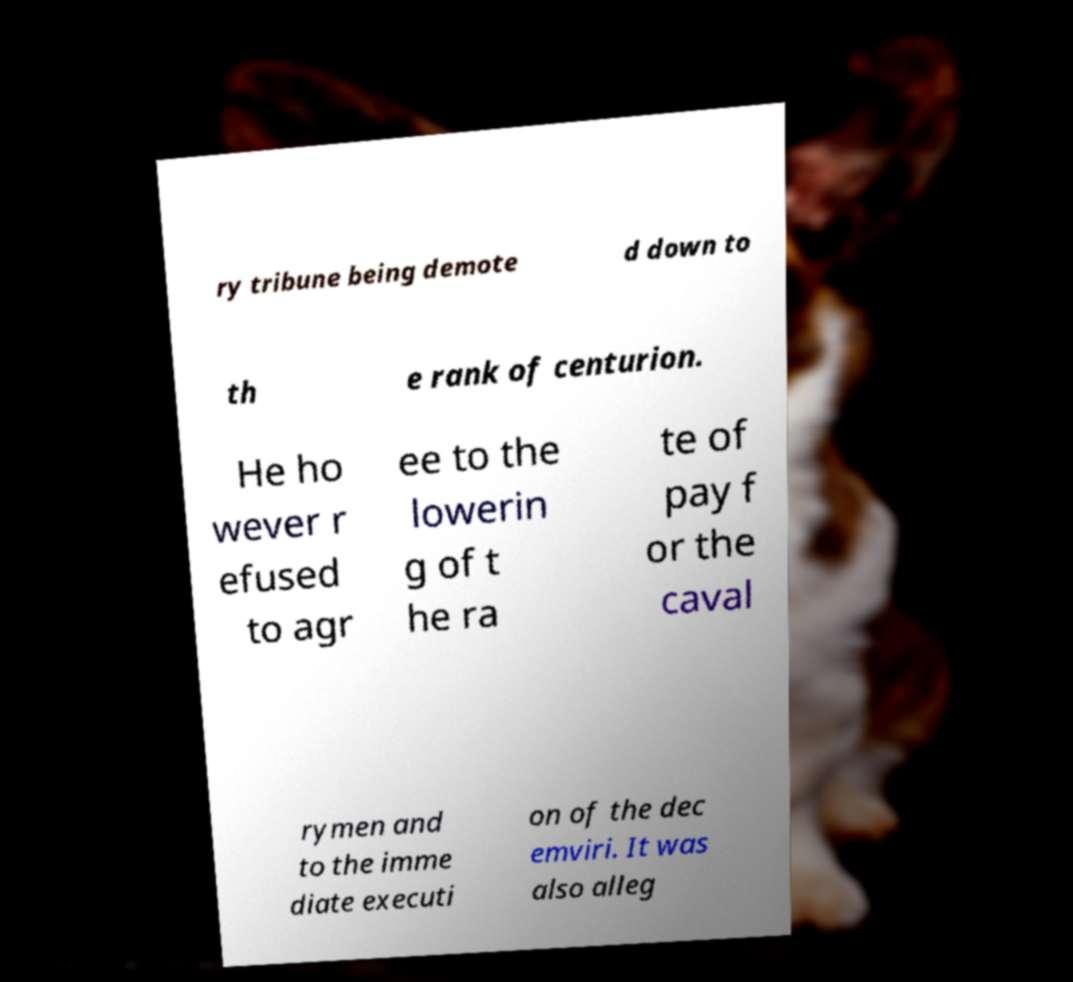Please identify and transcribe the text found in this image. ry tribune being demote d down to th e rank of centurion. He ho wever r efused to agr ee to the lowerin g of t he ra te of pay f or the caval rymen and to the imme diate executi on of the dec emviri. It was also alleg 